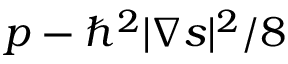Convert formula to latex. <formula><loc_0><loc_0><loc_500><loc_500>p - \hbar { ^ } { 2 } | \nabla s | ^ { 2 } / 8</formula> 